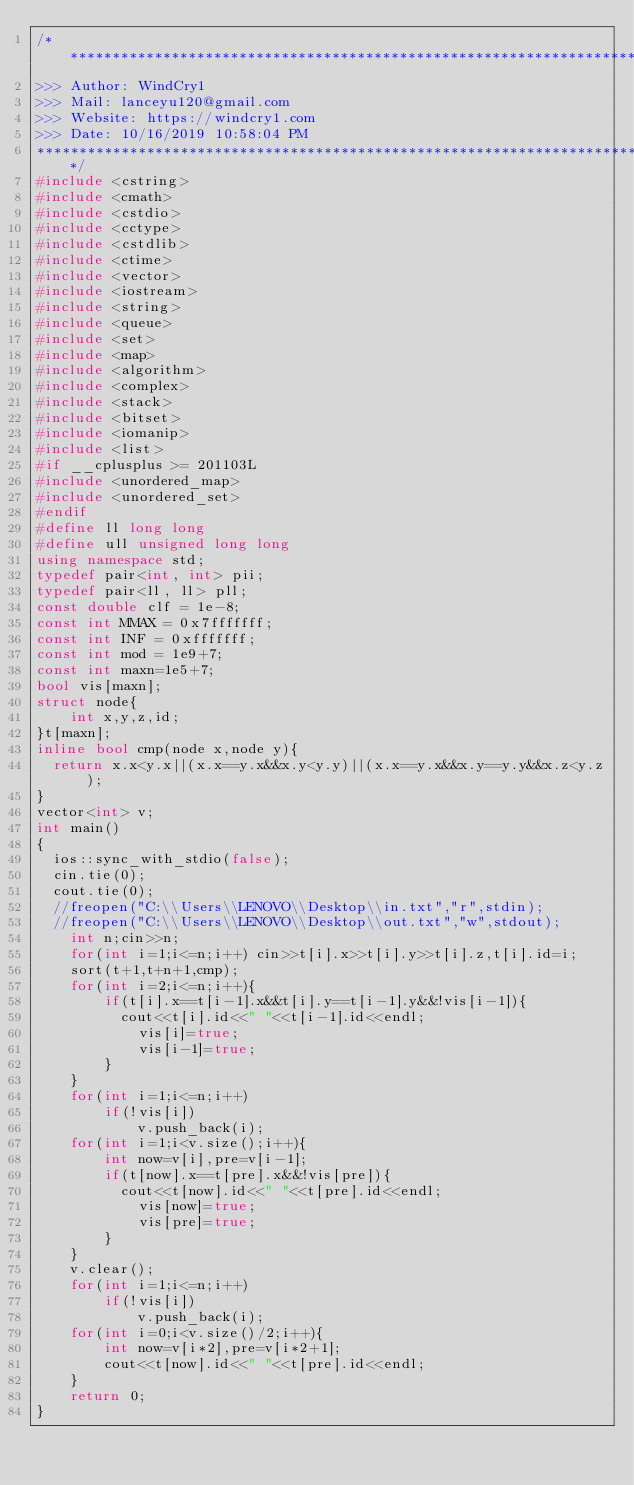Convert code to text. <code><loc_0><loc_0><loc_500><loc_500><_C++_>/*************************************************************************
>>> Author: WindCry1
>>> Mail: lanceyu120@gmail.com
>>> Website: https://windcry1.com
>>> Date: 10/16/2019 10:58:04 PM
*************************************************************************/
#include <cstring>
#include <cmath>
#include <cstdio>
#include <cctype>
#include <cstdlib>
#include <ctime>
#include <vector>
#include <iostream>
#include <string>
#include <queue>
#include <set>
#include <map>
#include <algorithm>
#include <complex>
#include <stack>
#include <bitset>
#include <iomanip>
#include <list>
#if __cplusplus >= 201103L
#include <unordered_map>
#include <unordered_set>
#endif
#define ll long long
#define ull unsigned long long
using namespace std;
typedef pair<int, int> pii;
typedef pair<ll, ll> pll;
const double clf = 1e-8;
const int MMAX = 0x7fffffff;
const int INF = 0xfffffff;
const int mod = 1e9+7;
const int maxn=1e5+7;
bool vis[maxn];
struct node{
    int x,y,z,id;
}t[maxn];
inline bool cmp(node x,node y){
	return x.x<y.x||(x.x==y.x&&x.y<y.y)||(x.x==y.x&&x.y==y.y&&x.z<y.z);
}
vector<int> v;
int main()
{
	ios::sync_with_stdio(false);
	cin.tie(0);
	cout.tie(0);
	//freopen("C:\\Users\\LENOVO\\Desktop\\in.txt","r",stdin);
	//freopen("C:\\Users\\LENOVO\\Desktop\\out.txt","w",stdout);
    int n;cin>>n;
    for(int i=1;i<=n;i++) cin>>t[i].x>>t[i].y>>t[i].z,t[i].id=i;
    sort(t+1,t+n+1,cmp);
    for(int i=2;i<=n;i++){
        if(t[i].x==t[i-1].x&&t[i].y==t[i-1].y&&!vis[i-1]){
        	cout<<t[i].id<<" "<<t[i-1].id<<endl;
            vis[i]=true;
            vis[i-1]=true;
        }
    }
    for(int i=1;i<=n;i++)
        if(!vis[i]) 
            v.push_back(i);
    for(int i=1;i<v.size();i++){
        int now=v[i],pre=v[i-1];
        if(t[now].x==t[pre].x&&!vis[pre]){
        	cout<<t[now].id<<" "<<t[pre].id<<endl;
            vis[now]=true;
            vis[pre]=true;
        }
    }
    v.clear();
    for(int i=1;i<=n;i++)
        if(!vis[i])
            v.push_back(i);
    for(int i=0;i<v.size()/2;i++){
        int now=v[i*2],pre=v[i*2+1];
        cout<<t[now].id<<" "<<t[pre].id<<endl;
    }
    return 0;
}

</code> 